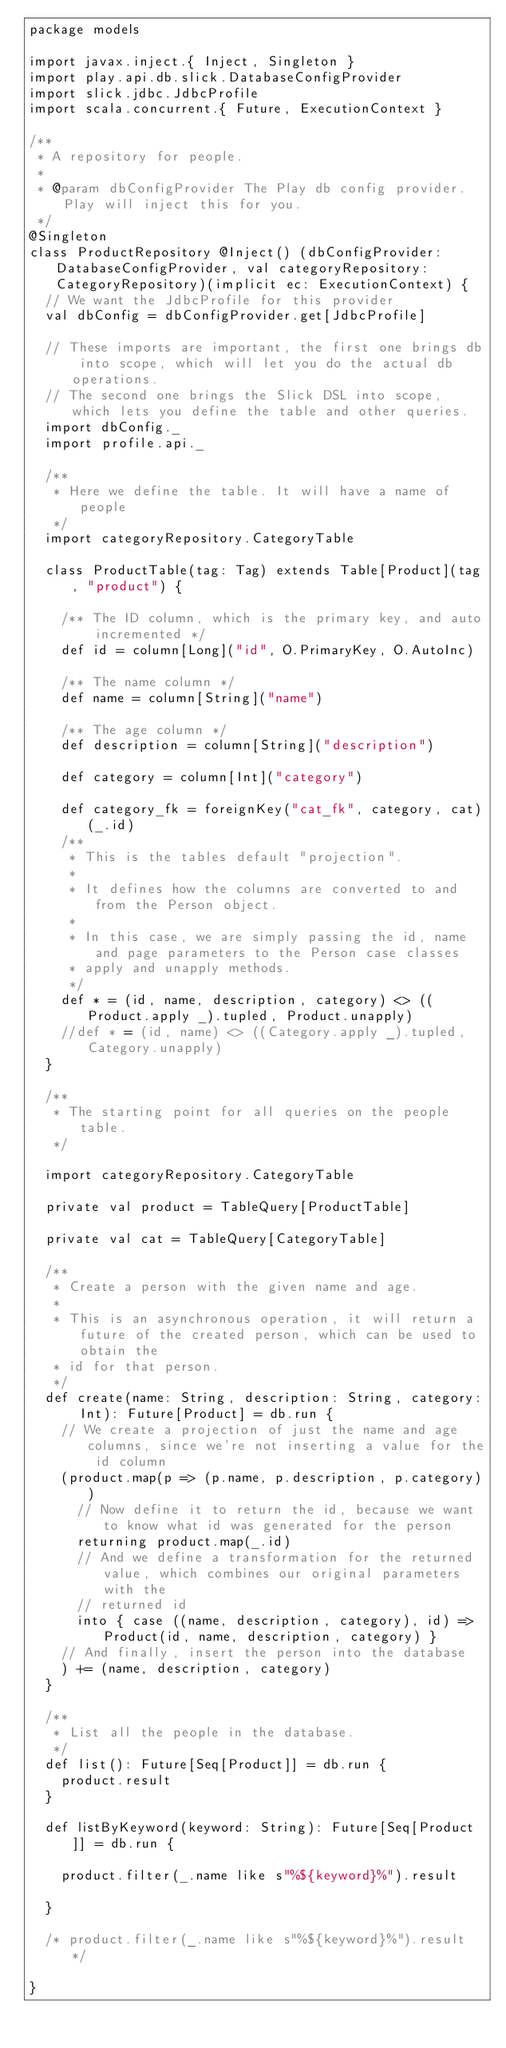Convert code to text. <code><loc_0><loc_0><loc_500><loc_500><_Scala_>package models

import javax.inject.{ Inject, Singleton }
import play.api.db.slick.DatabaseConfigProvider
import slick.jdbc.JdbcProfile
import scala.concurrent.{ Future, ExecutionContext }

/**
 * A repository for people.
 *
 * @param dbConfigProvider The Play db config provider. Play will inject this for you.
 */
@Singleton
class ProductRepository @Inject() (dbConfigProvider: DatabaseConfigProvider, val categoryRepository: CategoryRepository)(implicit ec: ExecutionContext) {
  // We want the JdbcProfile for this provider
  val dbConfig = dbConfigProvider.get[JdbcProfile]

  // These imports are important, the first one brings db into scope, which will let you do the actual db operations.
  // The second one brings the Slick DSL into scope, which lets you define the table and other queries.
  import dbConfig._
  import profile.api._

  /**
   * Here we define the table. It will have a name of people
   */
  import categoryRepository.CategoryTable

  class ProductTable(tag: Tag) extends Table[Product](tag, "product") {

    /** The ID column, which is the primary key, and auto incremented */
    def id = column[Long]("id", O.PrimaryKey, O.AutoInc)

    /** The name column */
    def name = column[String]("name")

    /** The age column */
    def description = column[String]("description")

    def category = column[Int]("category")

    def category_fk = foreignKey("cat_fk", category, cat)(_.id)
    /**
     * This is the tables default "projection".
     *
     * It defines how the columns are converted to and from the Person object.
     *
     * In this case, we are simply passing the id, name and page parameters to the Person case classes
     * apply and unapply methods.
     */
    def * = (id, name, description, category) <> ((Product.apply _).tupled, Product.unapply)
    //def * = (id, name) <> ((Category.apply _).tupled, Category.unapply)
  }

  /**
   * The starting point for all queries on the people table.
   */

  import categoryRepository.CategoryTable

  private val product = TableQuery[ProductTable]

  private val cat = TableQuery[CategoryTable]

  /**
   * Create a person with the given name and age.
   *
   * This is an asynchronous operation, it will return a future of the created person, which can be used to obtain the
   * id for that person.
   */
  def create(name: String, description: String, category: Int): Future[Product] = db.run {
    // We create a projection of just the name and age columns, since we're not inserting a value for the id column
    (product.map(p => (p.name, p.description, p.category))
      // Now define it to return the id, because we want to know what id was generated for the person
      returning product.map(_.id)
      // And we define a transformation for the returned value, which combines our original parameters with the
      // returned id
      into { case ((name, description, category), id) => Product(id, name, description, category) }
    // And finally, insert the person into the database
    ) += (name, description, category)
  }

  /**
   * List all the people in the database.
   */
  def list(): Future[Seq[Product]] = db.run {
    product.result
  }

  def listByKeyword(keyword: String): Future[Seq[Product]] = db.run {

    product.filter(_.name like s"%${keyword}%").result

  }

  /* product.filter(_.name like s"%${keyword}%").result */

}
</code> 